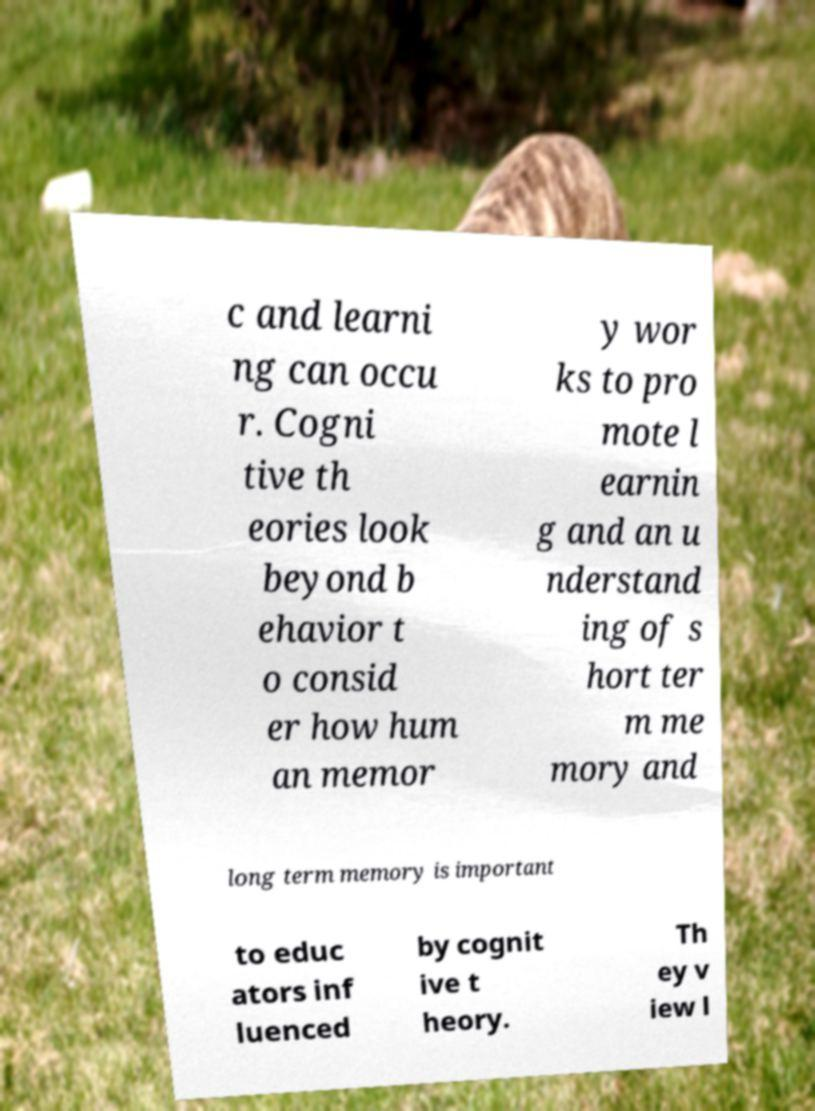What messages or text are displayed in this image? I need them in a readable, typed format. c and learni ng can occu r. Cogni tive th eories look beyond b ehavior t o consid er how hum an memor y wor ks to pro mote l earnin g and an u nderstand ing of s hort ter m me mory and long term memory is important to educ ators inf luenced by cognit ive t heory. Th ey v iew l 